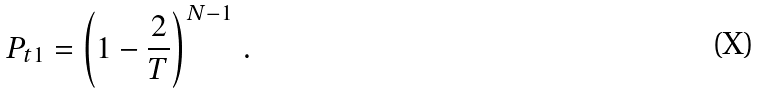<formula> <loc_0><loc_0><loc_500><loc_500>P _ { t 1 } = \left ( 1 - \frac { 2 } { T } \right ) ^ { N - 1 } \, .</formula> 